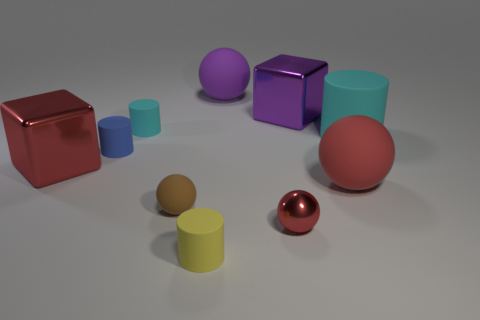Subtract all purple spheres. How many spheres are left? 3 Subtract all yellow cylinders. How many cylinders are left? 3 Subtract all red cylinders. Subtract all gray cubes. How many cylinders are left? 4 Subtract all blocks. How many objects are left? 8 Subtract all red matte things. Subtract all large rubber cylinders. How many objects are left? 8 Add 7 large purple spheres. How many large purple spheres are left? 8 Add 7 purple matte objects. How many purple matte objects exist? 8 Subtract 2 red balls. How many objects are left? 8 